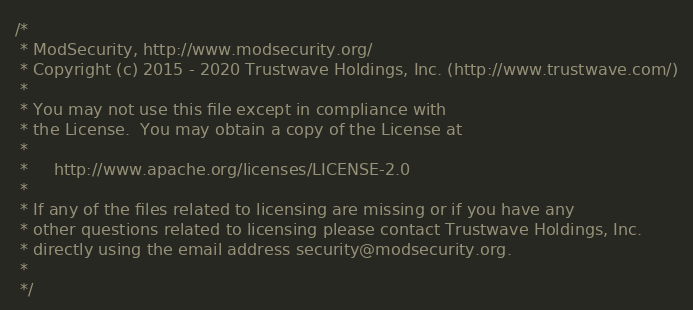<code> <loc_0><loc_0><loc_500><loc_500><_C++_>/*
 * ModSecurity, http://www.modsecurity.org/
 * Copyright (c) 2015 - 2020 Trustwave Holdings, Inc. (http://www.trustwave.com/)
 *
 * You may not use this file except in compliance with
 * the License.  You may obtain a copy of the License at
 *
 *     http://www.apache.org/licenses/LICENSE-2.0
 *
 * If any of the files related to licensing are missing or if you have any
 * other questions related to licensing please contact Trustwave Holdings, Inc.
 * directly using the email address security@modsecurity.org.
 *
 */
</code> 